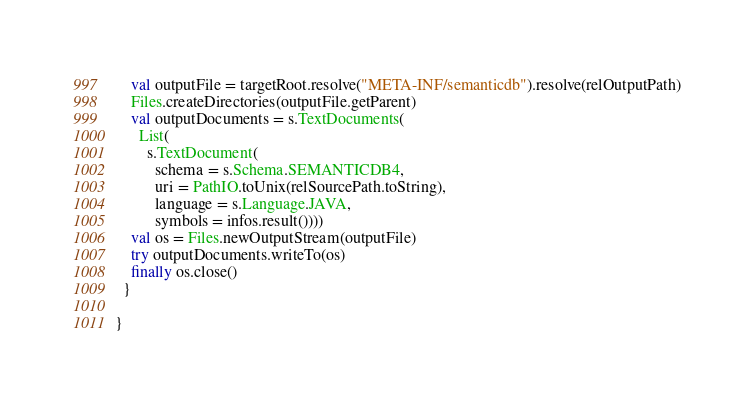Convert code to text. <code><loc_0><loc_0><loc_500><loc_500><_Scala_>    val outputFile = targetRoot.resolve("META-INF/semanticdb").resolve(relOutputPath)
    Files.createDirectories(outputFile.getParent)
    val outputDocuments = s.TextDocuments(
      List(
        s.TextDocument(
          schema = s.Schema.SEMANTICDB4,
          uri = PathIO.toUnix(relSourcePath.toString),
          language = s.Language.JAVA,
          symbols = infos.result())))
    val os = Files.newOutputStream(outputFile)
    try outputDocuments.writeTo(os)
    finally os.close()
  }

}
</code> 